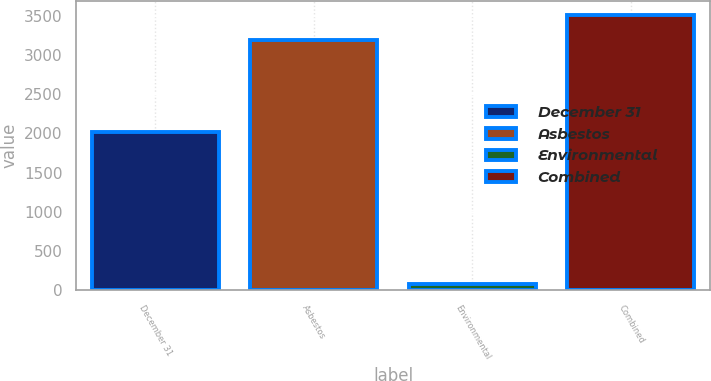<chart> <loc_0><loc_0><loc_500><loc_500><bar_chart><fcel>December 31<fcel>Asbestos<fcel>Environmental<fcel>Combined<nl><fcel>2012<fcel>3193<fcel>75<fcel>3512.3<nl></chart> 